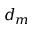Convert formula to latex. <formula><loc_0><loc_0><loc_500><loc_500>d _ { m }</formula> 